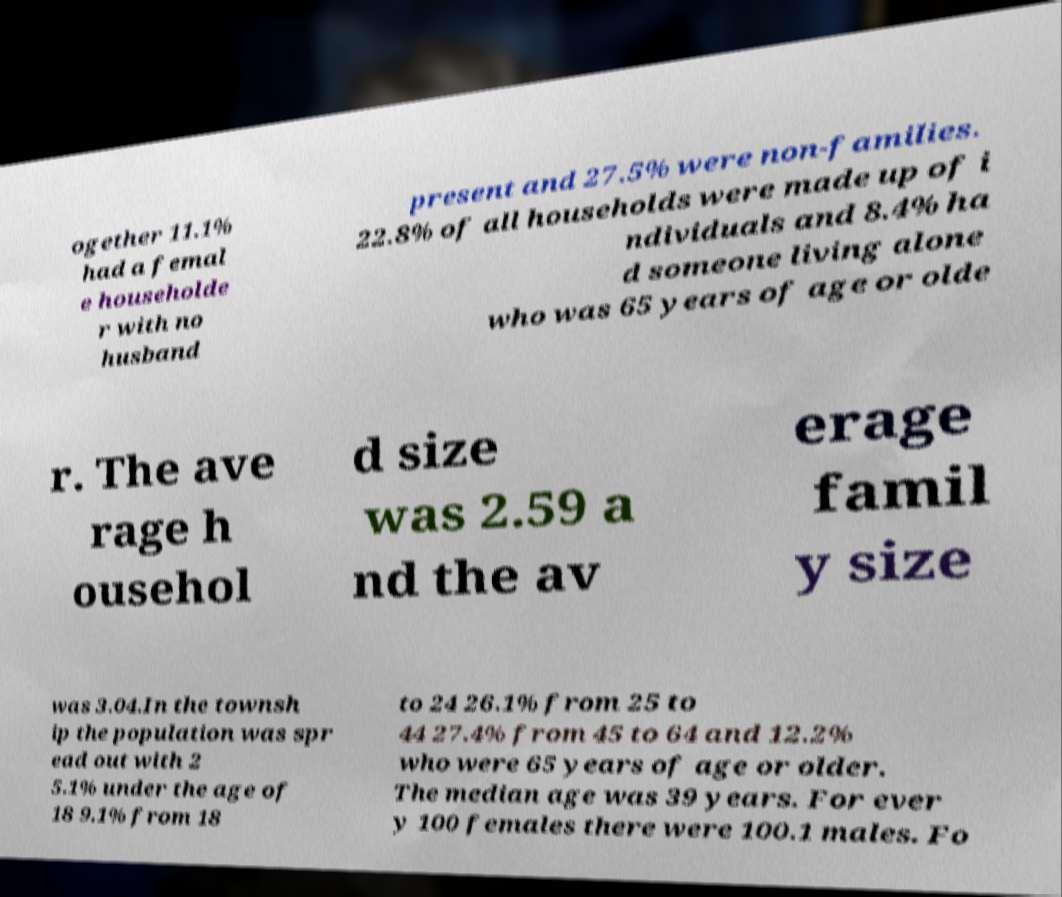There's text embedded in this image that I need extracted. Can you transcribe it verbatim? ogether 11.1% had a femal e householde r with no husband present and 27.5% were non-families. 22.8% of all households were made up of i ndividuals and 8.4% ha d someone living alone who was 65 years of age or olde r. The ave rage h ousehol d size was 2.59 a nd the av erage famil y size was 3.04.In the townsh ip the population was spr ead out with 2 5.1% under the age of 18 9.1% from 18 to 24 26.1% from 25 to 44 27.4% from 45 to 64 and 12.2% who were 65 years of age or older. The median age was 39 years. For ever y 100 females there were 100.1 males. Fo 